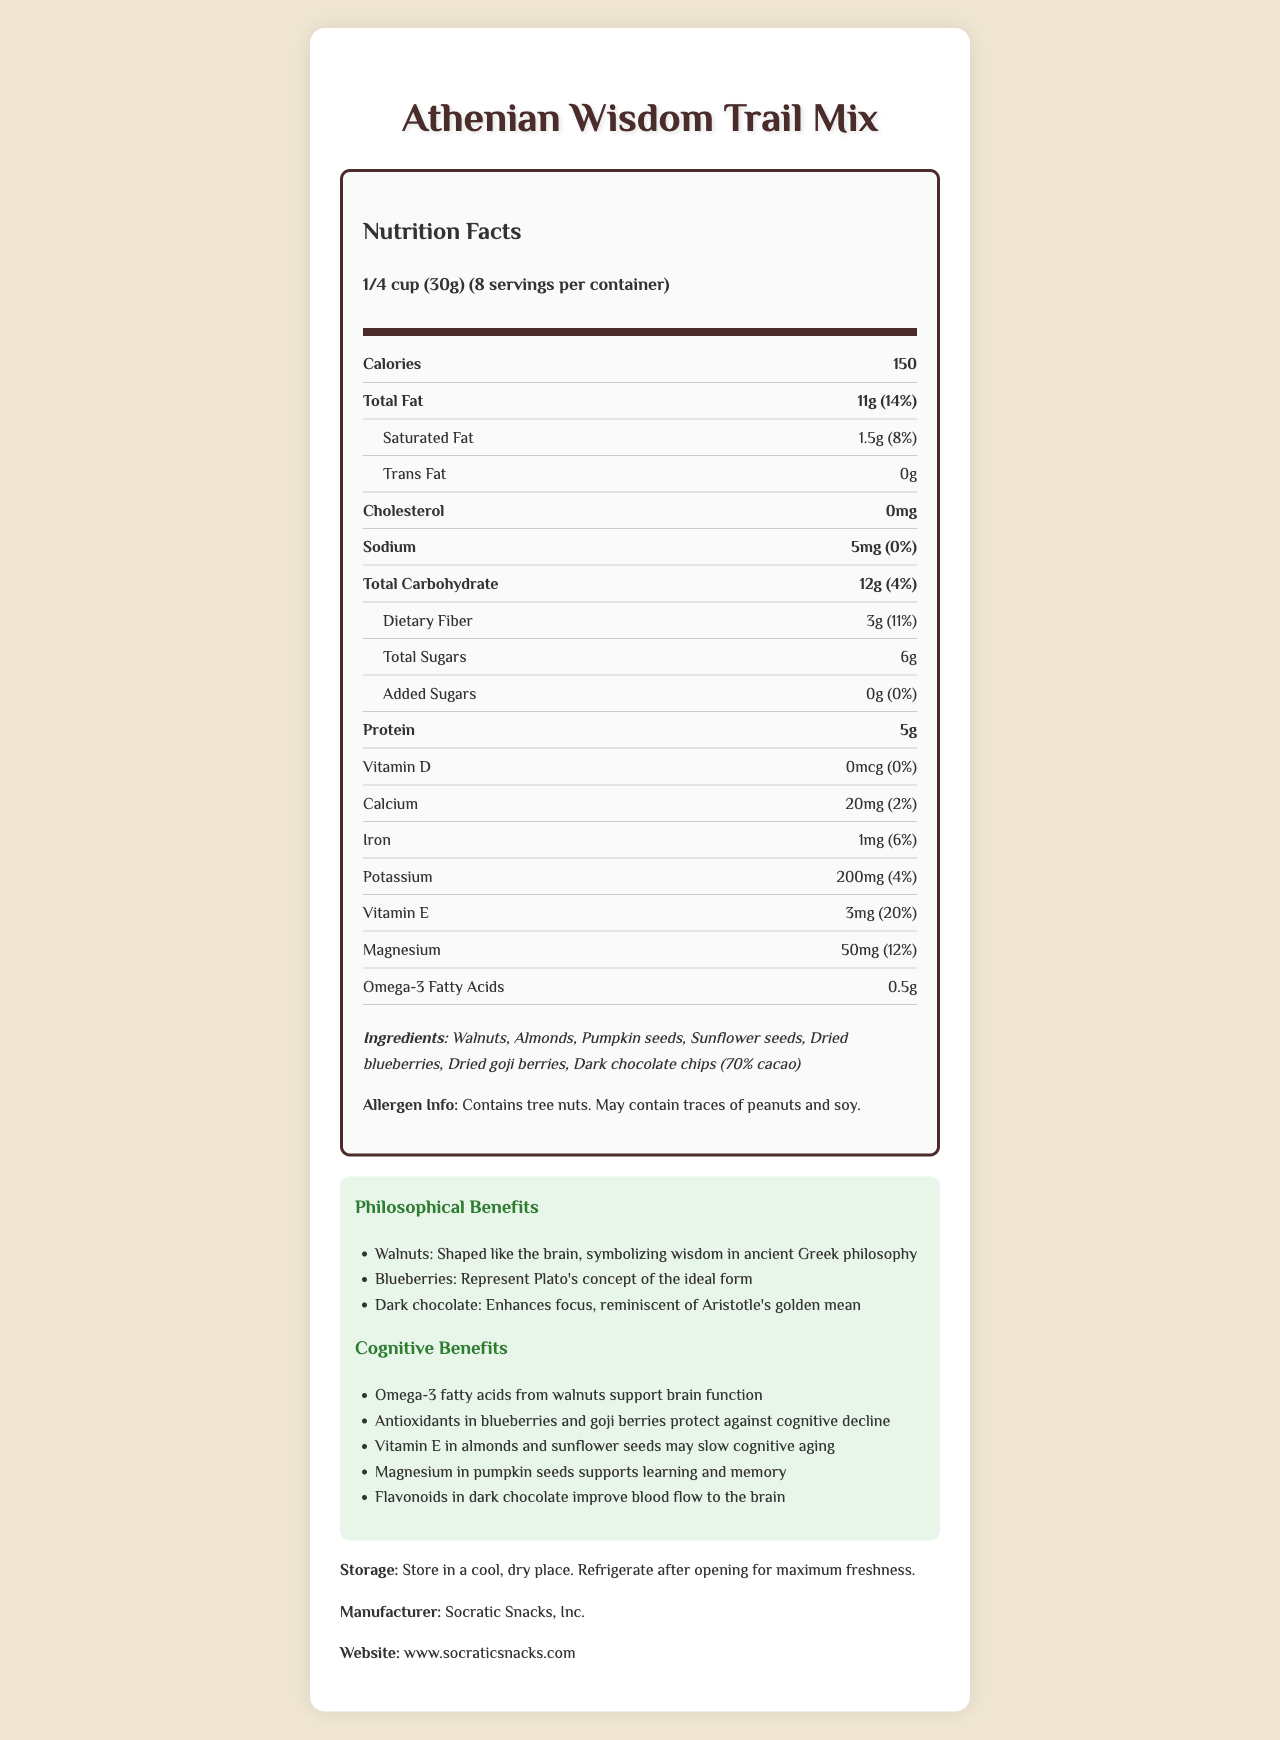what is the serving size of Athenian Wisdom Trail Mix? The serving size is clearly stated in the nutrition facts section at the top of the document.
Answer: 1/4 cup (30g) how many calories are in one serving of Athenian Wisdom Trail Mix? The calories per serving are listed as 150 in the nutrition facts section.
Answer: 150 calories which ingredient in Athenian Wisdom Trail Mix is rich in omega-3 fatty acids? The cognitive benefits section mentions that omega-3 fatty acids come from walnuts.
Answer: Walnuts what percent of daily value for magnesium does one serving provide? The nutrition facts section lists magnesium as providing 12% of the daily value.
Answer: 12% does Athenian Wisdom Trail Mix contain any added sugars? The nutrition facts section indicates that the amount of added sugars is 0g.
Answer: No which cognitive benefit is provided by the flavonoids in dark chocolate? The cognitive benefits section states that flavonoids in dark chocolate improve blood flow to the brain.
Answer: Improve blood flow to the brain how much dietary fiber is in one serving? The nutrition facts section lists the amount of dietary fiber per serving as 3g.
Answer: 3g which of the following ingredients is not listed in Athenian Wisdom Trail Mix? A. Walnuts B. Almonds C. Cashews D. Dark chocolate chips The ingredients listed are walnuts, almonds, pumpkin seeds, sunflower seeds, dried blueberries, dried goji berries, and dark chocolate chips.
Answer: C. Cashews how many servings are in one container of Athenian Wisdom Trail Mix? A. 6 B. 7 C. 8 D. 9 The nutrition facts section states that there are 8 servings per container.
Answer: C. 8 is there any cholesterol in Athenian Wisdom Trail Mix? The nutrition facts section indicates that the cholesterol is 0mg.
Answer: No does Athenian Wisdom Trail Mix contain any soy? The allergen information section states that the product may contain traces of soy.
Answer: May contain traces of soy how does the product relate to ancient Greek philosophy? The philosophical benefits section explains that various ingredients symbolize ancient Greek philosophy: walnuts symbolize wisdom, blueberries represent Plato's concept of the ideal form, and dark chocolate enhances focus, reminiscent of Aristotle's golden mean.
Answer: It symbolizes wisdom and concepts from Plato and Aristotle summarize the main nutritional and cognitive benefits of Athenian Wisdom Trail Mix. The summary involves multiple elements from the cognitive benefits section and nutritional facts, emphasizing the product's contribution to brain health.
Answer: Athenian Wisdom Trail Mix offers a range of nutritional and cognitive benefits, including omega-3 fatty acids from walnuts to support brain function, antioxidants from blueberries and goji berries to protect against cognitive decline, vitamin E in almonds and sunflower seeds that may slow cognitive aging, magnesium in pumpkin seeds that supports learning and memory, and flavonoids in dark chocolate that improve blood flow to the brain. what is the exact manufacturing date of this product? The document does not provide the manufacturing date, so it's impossible to determine from the available visual information.
Answer: Not enough information 